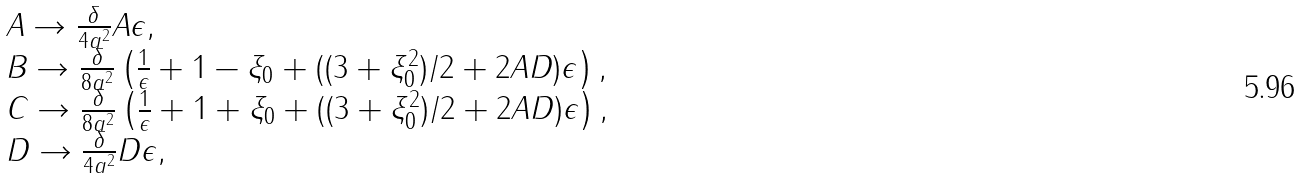Convert formula to latex. <formula><loc_0><loc_0><loc_500><loc_500>\begin{array} { l } A \rightarrow \frac { \delta } { 4 a ^ { 2 } } A \epsilon , \\ B \rightarrow \frac { \delta } { 8 a ^ { 2 } } \left ( \frac { 1 } { \epsilon } + 1 - \xi _ { 0 } + ( ( 3 + \xi _ { 0 } ^ { 2 } ) / 2 + 2 A D ) \epsilon \right ) , \\ C \rightarrow \frac { \delta } { 8 a ^ { 2 } } \left ( \frac { 1 } { \epsilon } + 1 + \xi _ { 0 } + ( ( 3 + \xi _ { 0 } ^ { 2 } ) / 2 + 2 A D ) \epsilon \right ) , \\ D \rightarrow \frac { \delta } { 4 a ^ { 2 } } D \epsilon , \\ \end{array}</formula> 